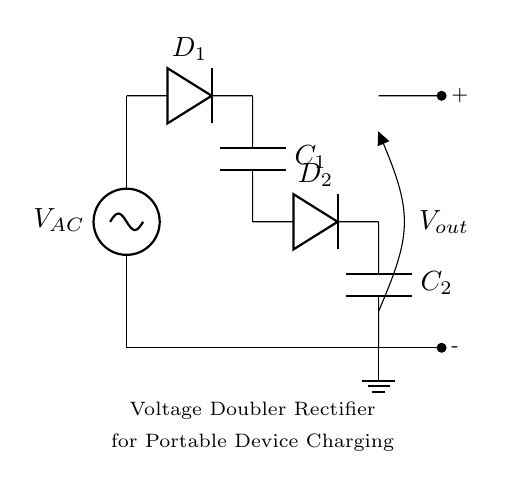What is the type of rectifier shown? This is a voltage doubler rectifier. The circuit employs two diodes and two capacitors to increase the output voltage to double that of the input AC voltage.
Answer: voltage doubler rectifier How many diodes are used in this circuit? The circuit uses two diodes, marked as D1 and D2. They are connected in succession to allow current flow during different phases of the AC voltage cycle.
Answer: two What are the components in this circuit diagram? The components include two diodes (D1 and D2), two capacitors (C1 and C2), and an AC voltage source (V_AC). All these components work together to convert AC to a higher DC voltage.
Answer: diodes, capacitors, AC source What is the purpose of the capacitors in this rectifier? The capacitors (C1 and C2) store charge, smoothing and doubling the output voltage by accumulating energy and releasing it during the rectification process. This is essential for providing stable output for charging devices.
Answer: to store charge What is the output voltage in relation to the input AC voltage? The output voltage is theoretically double the input AC voltage. This is characteristic of a voltage doubler circuit where the output voltage peaks at twice the peak value of the input sine wave.
Answer: double the input AC voltage During which half of the AC cycle does D1 conduct? D1 conducts during the positive half-cycle of the AC input voltage. When the input goes positive with respect to the ground, D1 becomes forward-biased, allowing current to flow through and charge C1.
Answer: positive half-cycle What happens to the output voltage when the load is connected? When a load is connected, the output voltage will drop due to the load drawing current from the capacitors. This voltage drop depends on the load impedance and the capacitors' ability to maintain charge.
Answer: it will drop 